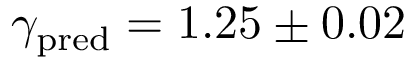<formula> <loc_0><loc_0><loc_500><loc_500>\gamma _ { p r e d } = 1 . 2 5 \pm 0 . 0 2</formula> 